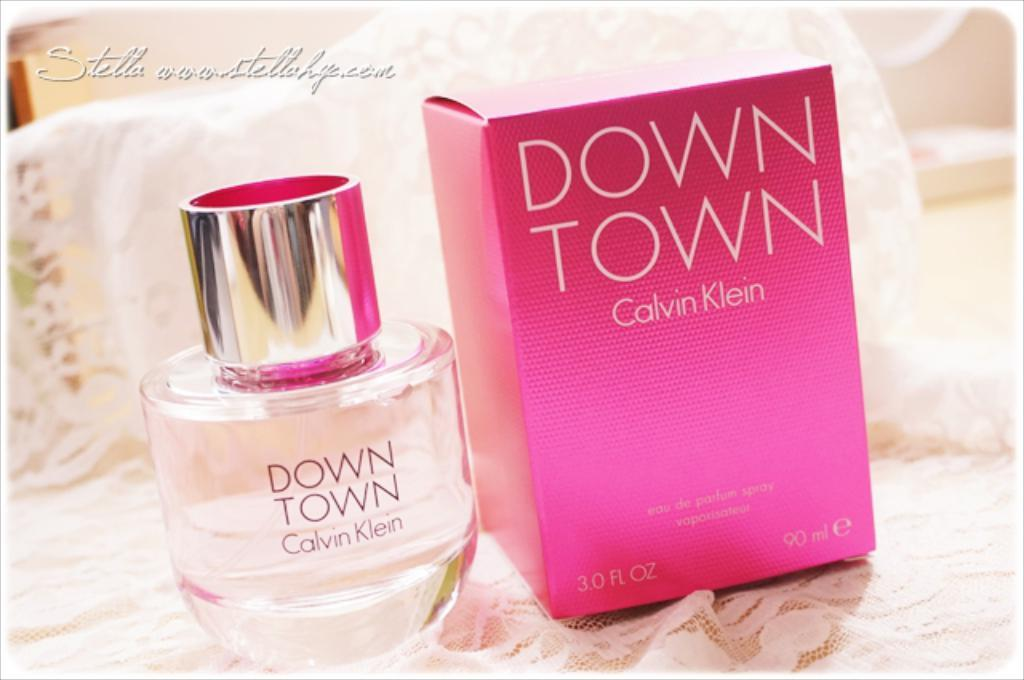<image>
Offer a succinct explanation of the picture presented. A bottle of down town by calvin klein branded perfume with its corresponding box. 